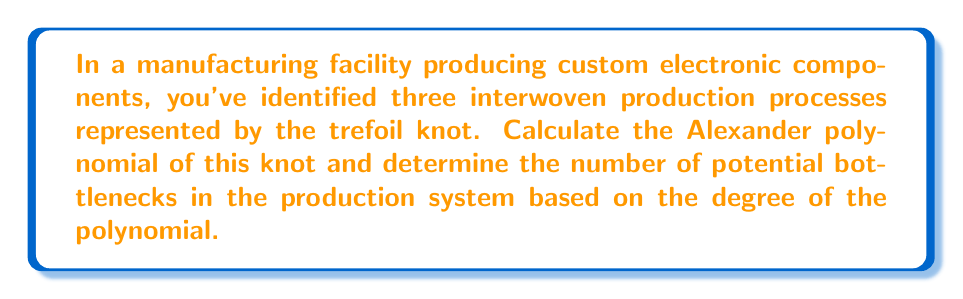What is the answer to this math problem? Let's approach this step-by-step:

1) The trefoil knot is one of the simplest non-trivial knots. Its Alexander polynomial is given by:

   $$\Delta(t) = t - 1 + t^{-1}$$

2) To standardize the polynomial, we multiply by the highest power of t to make all exponents non-negative:

   $$\Delta(t) = t^2 - t + 1$$

3) The degree of this polynomial is 2.

4) In the context of production processes, each term in the Alexander polynomial can be interpreted as representing a distinct phase or complexity level in the process.

5) The degree of the polynomial (2 in this case) represents the number of transitions between these phases, which can be potential bottlenecks in the production system.

6) Therefore, the number of potential bottlenecks is equal to the degree of the Alexander polynomial, which is 2.

This analysis suggests that there are two main points in the production process where bottlenecks are likely to occur, corresponding to the transitions between the three phases represented by the terms of the polynomial.
Answer: 2 potential bottlenecks 